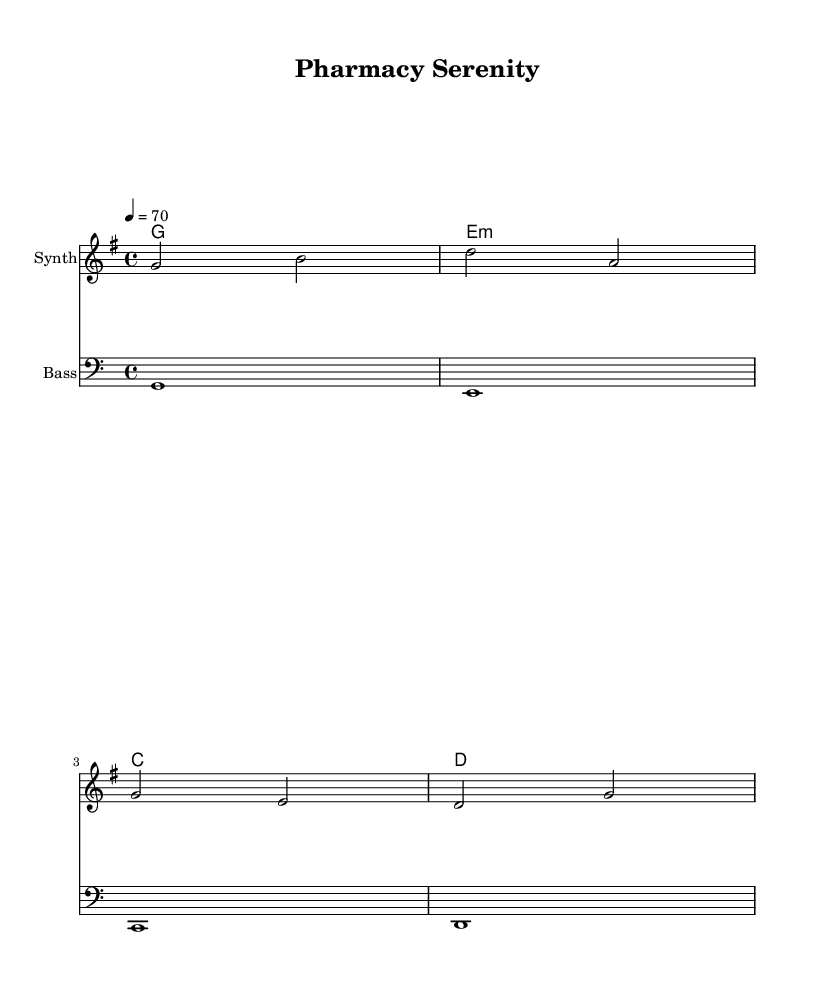What is the key signature of this music? The key signature is G major, which has one sharp.
Answer: G major What is the time signature of the piece? The time signature is 4/4, indicating four beats per measure.
Answer: 4/4 What is the tempo marking for this piece? The tempo marking indicates a speed of 70 beats per minute, suggesting a slow and relaxing pace.
Answer: 70 How many measures are in the melody section? The melody section has four measures, which can be counted from the notes presented.
Answer: Four measures What is the name of the second instrument used in the score? The second instrument is labeled as "Bass," which accompanies the melody and harmonies.
Answer: Bass What type of chord progression is illustrated in the harmonies? The harmonies show a progression of G major to E minor, C major, and D major, indicating a common dance track structure.
Answer: G, E minor, C, D What is the role of the bass in this piece? The bass plays the lower notes that support the harmony and melody, providing a foundational rhythm for the dance style.
Answer: Support harmony 